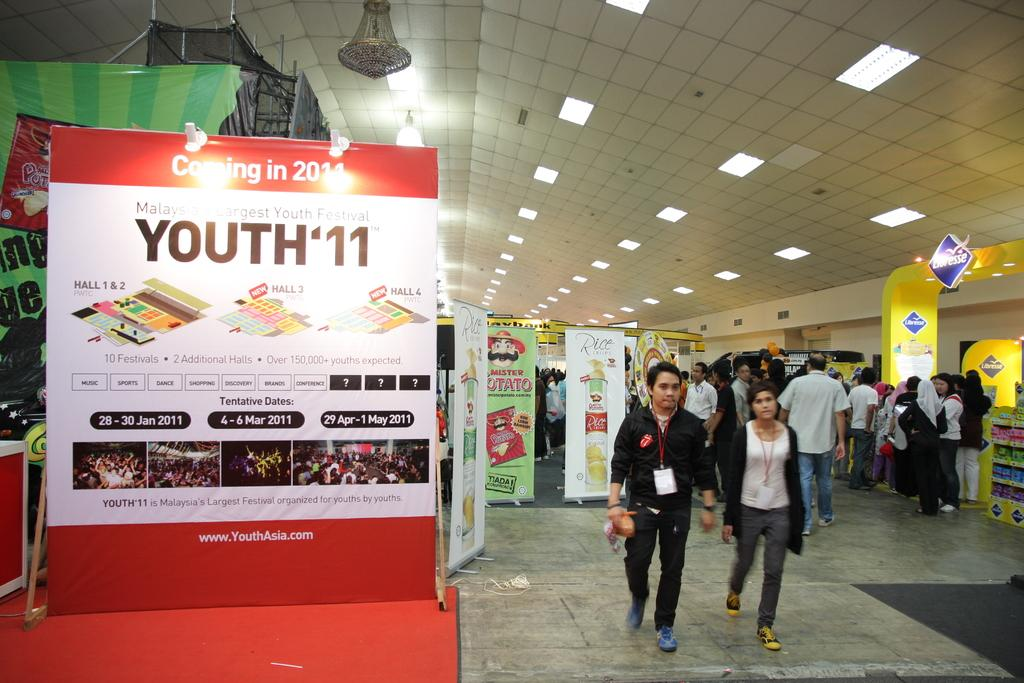Provide a one-sentence caption for the provided image. Youth '11 claims it is Malaysia's largest youth festival. 